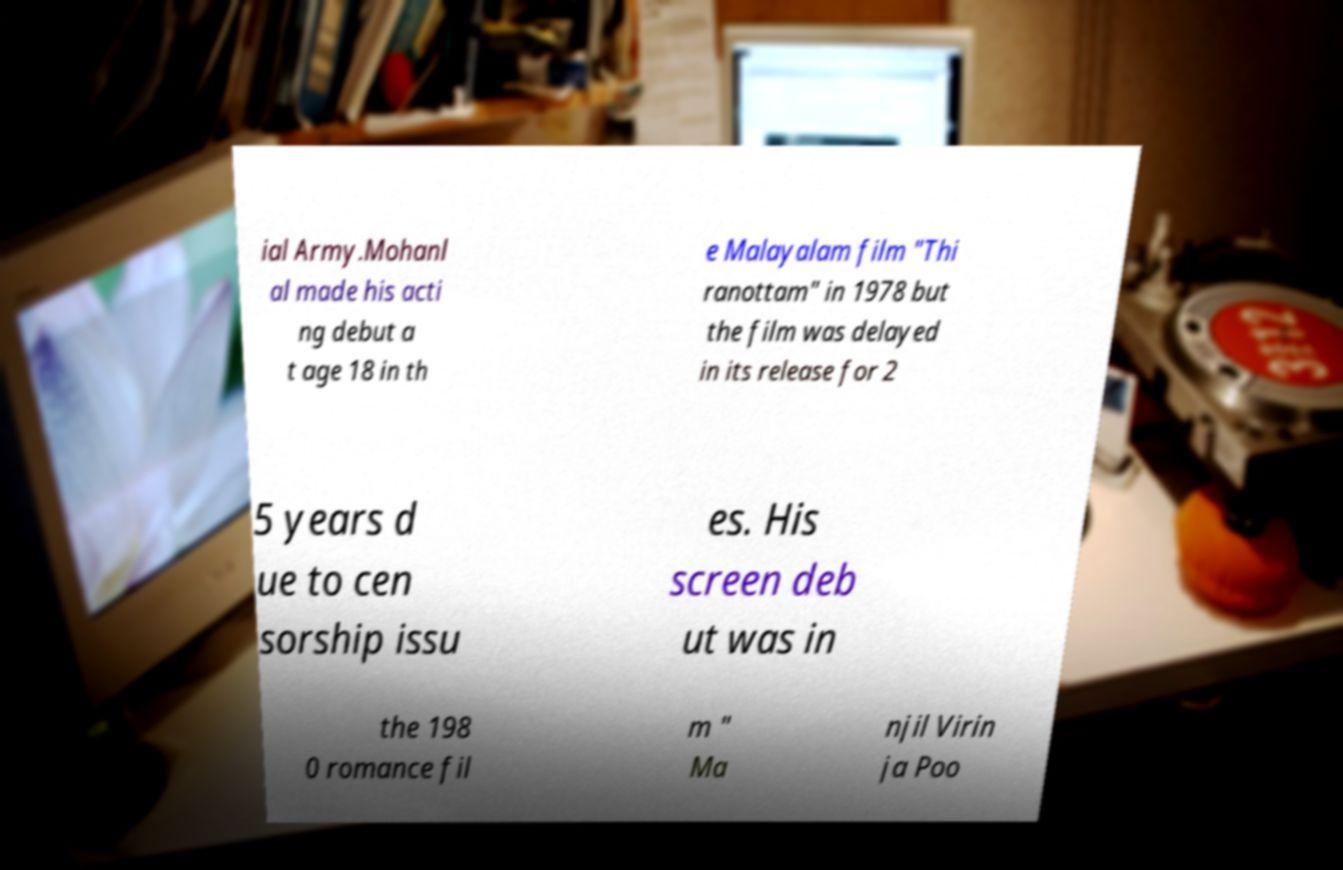There's text embedded in this image that I need extracted. Can you transcribe it verbatim? ial Army.Mohanl al made his acti ng debut a t age 18 in th e Malayalam film "Thi ranottam" in 1978 but the film was delayed in its release for 2 5 years d ue to cen sorship issu es. His screen deb ut was in the 198 0 romance fil m " Ma njil Virin ja Poo 